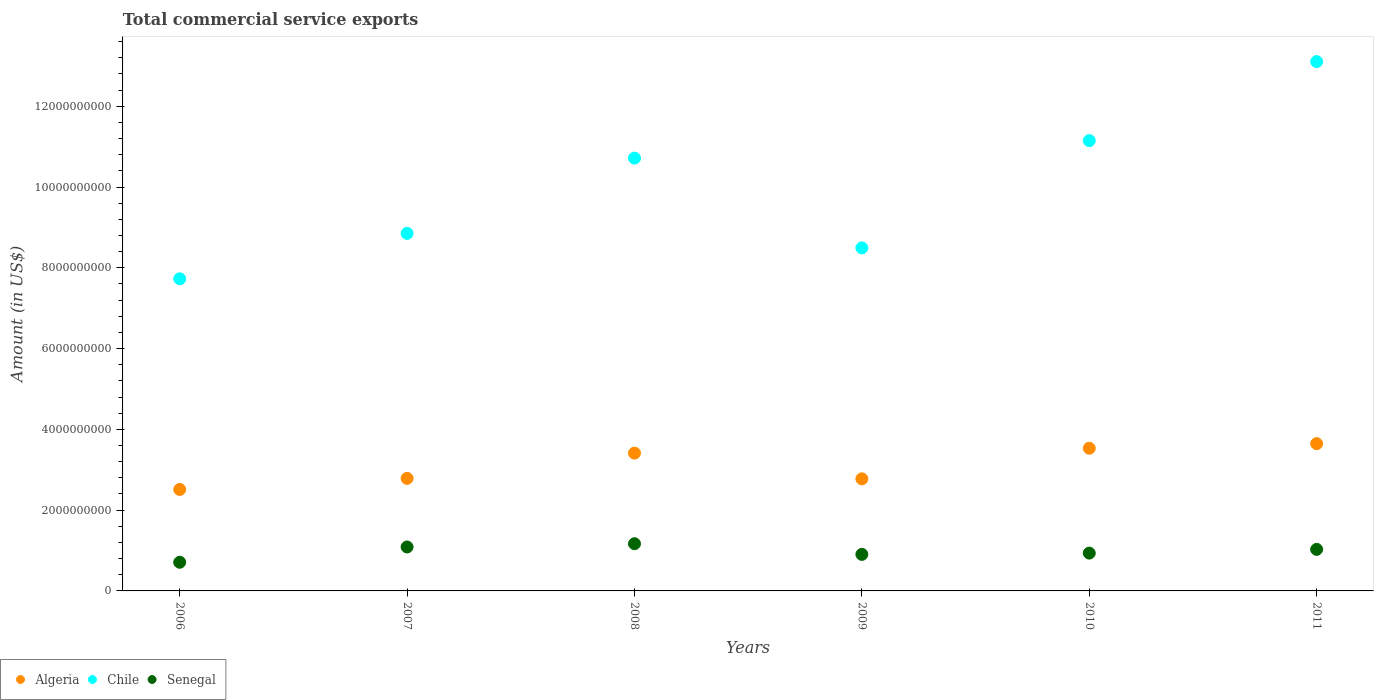How many different coloured dotlines are there?
Provide a short and direct response. 3. What is the total commercial service exports in Senegal in 2009?
Offer a terse response. 9.05e+08. Across all years, what is the maximum total commercial service exports in Algeria?
Your response must be concise. 3.65e+09. Across all years, what is the minimum total commercial service exports in Senegal?
Make the answer very short. 7.10e+08. In which year was the total commercial service exports in Algeria maximum?
Your answer should be compact. 2011. In which year was the total commercial service exports in Senegal minimum?
Your answer should be compact. 2006. What is the total total commercial service exports in Chile in the graph?
Ensure brevity in your answer.  6.00e+1. What is the difference between the total commercial service exports in Senegal in 2010 and that in 2011?
Make the answer very short. -9.23e+07. What is the difference between the total commercial service exports in Chile in 2006 and the total commercial service exports in Algeria in 2011?
Keep it short and to the point. 4.08e+09. What is the average total commercial service exports in Chile per year?
Make the answer very short. 1.00e+1. In the year 2006, what is the difference between the total commercial service exports in Algeria and total commercial service exports in Chile?
Ensure brevity in your answer.  -5.22e+09. In how many years, is the total commercial service exports in Chile greater than 9600000000 US$?
Ensure brevity in your answer.  3. What is the ratio of the total commercial service exports in Algeria in 2006 to that in 2007?
Provide a short and direct response. 0.9. What is the difference between the highest and the second highest total commercial service exports in Algeria?
Give a very brief answer. 1.14e+08. What is the difference between the highest and the lowest total commercial service exports in Chile?
Your answer should be very brief. 5.38e+09. In how many years, is the total commercial service exports in Senegal greater than the average total commercial service exports in Senegal taken over all years?
Make the answer very short. 3. Is the total commercial service exports in Senegal strictly greater than the total commercial service exports in Algeria over the years?
Provide a succinct answer. No. What is the difference between two consecutive major ticks on the Y-axis?
Keep it short and to the point. 2.00e+09. Are the values on the major ticks of Y-axis written in scientific E-notation?
Provide a succinct answer. No. Does the graph contain any zero values?
Ensure brevity in your answer.  No. Does the graph contain grids?
Offer a very short reply. No. Where does the legend appear in the graph?
Ensure brevity in your answer.  Bottom left. How many legend labels are there?
Give a very brief answer. 3. How are the legend labels stacked?
Provide a short and direct response. Horizontal. What is the title of the graph?
Make the answer very short. Total commercial service exports. Does "Korea (Democratic)" appear as one of the legend labels in the graph?
Keep it short and to the point. No. What is the label or title of the Y-axis?
Make the answer very short. Amount (in US$). What is the Amount (in US$) of Algeria in 2006?
Offer a terse response. 2.51e+09. What is the Amount (in US$) in Chile in 2006?
Offer a terse response. 7.73e+09. What is the Amount (in US$) of Senegal in 2006?
Give a very brief answer. 7.10e+08. What is the Amount (in US$) in Algeria in 2007?
Give a very brief answer. 2.79e+09. What is the Amount (in US$) of Chile in 2007?
Ensure brevity in your answer.  8.85e+09. What is the Amount (in US$) in Senegal in 2007?
Keep it short and to the point. 1.09e+09. What is the Amount (in US$) of Algeria in 2008?
Give a very brief answer. 3.41e+09. What is the Amount (in US$) of Chile in 2008?
Offer a terse response. 1.07e+1. What is the Amount (in US$) in Senegal in 2008?
Offer a terse response. 1.17e+09. What is the Amount (in US$) in Algeria in 2009?
Make the answer very short. 2.78e+09. What is the Amount (in US$) of Chile in 2009?
Ensure brevity in your answer.  8.49e+09. What is the Amount (in US$) in Senegal in 2009?
Provide a succinct answer. 9.05e+08. What is the Amount (in US$) in Algeria in 2010?
Ensure brevity in your answer.  3.53e+09. What is the Amount (in US$) of Chile in 2010?
Provide a succinct answer. 1.11e+1. What is the Amount (in US$) in Senegal in 2010?
Provide a succinct answer. 9.36e+08. What is the Amount (in US$) in Algeria in 2011?
Your answer should be compact. 3.65e+09. What is the Amount (in US$) in Chile in 2011?
Your response must be concise. 1.31e+1. What is the Amount (in US$) of Senegal in 2011?
Keep it short and to the point. 1.03e+09. Across all years, what is the maximum Amount (in US$) of Algeria?
Your answer should be very brief. 3.65e+09. Across all years, what is the maximum Amount (in US$) in Chile?
Give a very brief answer. 1.31e+1. Across all years, what is the maximum Amount (in US$) in Senegal?
Your response must be concise. 1.17e+09. Across all years, what is the minimum Amount (in US$) of Algeria?
Your answer should be very brief. 2.51e+09. Across all years, what is the minimum Amount (in US$) of Chile?
Provide a short and direct response. 7.73e+09. Across all years, what is the minimum Amount (in US$) in Senegal?
Keep it short and to the point. 7.10e+08. What is the total Amount (in US$) of Algeria in the graph?
Offer a terse response. 1.87e+1. What is the total Amount (in US$) of Chile in the graph?
Your response must be concise. 6.00e+1. What is the total Amount (in US$) in Senegal in the graph?
Offer a very short reply. 5.84e+09. What is the difference between the Amount (in US$) in Algeria in 2006 and that in 2007?
Offer a terse response. -2.75e+08. What is the difference between the Amount (in US$) of Chile in 2006 and that in 2007?
Your answer should be very brief. -1.12e+09. What is the difference between the Amount (in US$) of Senegal in 2006 and that in 2007?
Your answer should be very brief. -3.78e+08. What is the difference between the Amount (in US$) in Algeria in 2006 and that in 2008?
Ensure brevity in your answer.  -9.00e+08. What is the difference between the Amount (in US$) in Chile in 2006 and that in 2008?
Make the answer very short. -2.99e+09. What is the difference between the Amount (in US$) in Senegal in 2006 and that in 2008?
Your answer should be compact. -4.59e+08. What is the difference between the Amount (in US$) of Algeria in 2006 and that in 2009?
Your answer should be compact. -2.63e+08. What is the difference between the Amount (in US$) of Chile in 2006 and that in 2009?
Provide a short and direct response. -7.65e+08. What is the difference between the Amount (in US$) of Senegal in 2006 and that in 2009?
Offer a terse response. -1.95e+08. What is the difference between the Amount (in US$) in Algeria in 2006 and that in 2010?
Make the answer very short. -1.02e+09. What is the difference between the Amount (in US$) in Chile in 2006 and that in 2010?
Provide a short and direct response. -3.42e+09. What is the difference between the Amount (in US$) of Senegal in 2006 and that in 2010?
Keep it short and to the point. -2.27e+08. What is the difference between the Amount (in US$) in Algeria in 2006 and that in 2011?
Your answer should be very brief. -1.13e+09. What is the difference between the Amount (in US$) of Chile in 2006 and that in 2011?
Your answer should be very brief. -5.38e+09. What is the difference between the Amount (in US$) of Senegal in 2006 and that in 2011?
Your answer should be compact. -3.19e+08. What is the difference between the Amount (in US$) in Algeria in 2007 and that in 2008?
Provide a succinct answer. -6.26e+08. What is the difference between the Amount (in US$) of Chile in 2007 and that in 2008?
Offer a terse response. -1.86e+09. What is the difference between the Amount (in US$) in Senegal in 2007 and that in 2008?
Give a very brief answer. -8.07e+07. What is the difference between the Amount (in US$) of Algeria in 2007 and that in 2009?
Your answer should be very brief. 1.13e+07. What is the difference between the Amount (in US$) in Chile in 2007 and that in 2009?
Ensure brevity in your answer.  3.59e+08. What is the difference between the Amount (in US$) of Senegal in 2007 and that in 2009?
Ensure brevity in your answer.  1.83e+08. What is the difference between the Amount (in US$) of Algeria in 2007 and that in 2010?
Your answer should be compact. -7.46e+08. What is the difference between the Amount (in US$) of Chile in 2007 and that in 2010?
Provide a succinct answer. -2.30e+09. What is the difference between the Amount (in US$) in Senegal in 2007 and that in 2010?
Provide a succinct answer. 1.52e+08. What is the difference between the Amount (in US$) in Algeria in 2007 and that in 2011?
Your answer should be very brief. -8.60e+08. What is the difference between the Amount (in US$) of Chile in 2007 and that in 2011?
Keep it short and to the point. -4.25e+09. What is the difference between the Amount (in US$) in Senegal in 2007 and that in 2011?
Offer a terse response. 5.92e+07. What is the difference between the Amount (in US$) of Algeria in 2008 and that in 2009?
Your answer should be very brief. 6.37e+08. What is the difference between the Amount (in US$) in Chile in 2008 and that in 2009?
Your answer should be compact. 2.22e+09. What is the difference between the Amount (in US$) in Senegal in 2008 and that in 2009?
Ensure brevity in your answer.  2.64e+08. What is the difference between the Amount (in US$) of Algeria in 2008 and that in 2010?
Keep it short and to the point. -1.21e+08. What is the difference between the Amount (in US$) in Chile in 2008 and that in 2010?
Keep it short and to the point. -4.33e+08. What is the difference between the Amount (in US$) of Senegal in 2008 and that in 2010?
Make the answer very short. 2.32e+08. What is the difference between the Amount (in US$) of Algeria in 2008 and that in 2011?
Provide a succinct answer. -2.35e+08. What is the difference between the Amount (in US$) in Chile in 2008 and that in 2011?
Offer a very short reply. -2.39e+09. What is the difference between the Amount (in US$) in Senegal in 2008 and that in 2011?
Keep it short and to the point. 1.40e+08. What is the difference between the Amount (in US$) in Algeria in 2009 and that in 2010?
Offer a terse response. -7.57e+08. What is the difference between the Amount (in US$) of Chile in 2009 and that in 2010?
Offer a very short reply. -2.66e+09. What is the difference between the Amount (in US$) in Senegal in 2009 and that in 2010?
Offer a very short reply. -3.16e+07. What is the difference between the Amount (in US$) in Algeria in 2009 and that in 2011?
Your response must be concise. -8.71e+08. What is the difference between the Amount (in US$) of Chile in 2009 and that in 2011?
Ensure brevity in your answer.  -4.61e+09. What is the difference between the Amount (in US$) of Senegal in 2009 and that in 2011?
Your response must be concise. -1.24e+08. What is the difference between the Amount (in US$) of Algeria in 2010 and that in 2011?
Ensure brevity in your answer.  -1.14e+08. What is the difference between the Amount (in US$) of Chile in 2010 and that in 2011?
Your answer should be very brief. -1.96e+09. What is the difference between the Amount (in US$) of Senegal in 2010 and that in 2011?
Your answer should be very brief. -9.23e+07. What is the difference between the Amount (in US$) in Algeria in 2006 and the Amount (in US$) in Chile in 2007?
Offer a terse response. -6.34e+09. What is the difference between the Amount (in US$) in Algeria in 2006 and the Amount (in US$) in Senegal in 2007?
Your answer should be compact. 1.42e+09. What is the difference between the Amount (in US$) of Chile in 2006 and the Amount (in US$) of Senegal in 2007?
Ensure brevity in your answer.  6.64e+09. What is the difference between the Amount (in US$) of Algeria in 2006 and the Amount (in US$) of Chile in 2008?
Offer a very short reply. -8.20e+09. What is the difference between the Amount (in US$) in Algeria in 2006 and the Amount (in US$) in Senegal in 2008?
Provide a short and direct response. 1.34e+09. What is the difference between the Amount (in US$) of Chile in 2006 and the Amount (in US$) of Senegal in 2008?
Your answer should be very brief. 6.56e+09. What is the difference between the Amount (in US$) in Algeria in 2006 and the Amount (in US$) in Chile in 2009?
Ensure brevity in your answer.  -5.98e+09. What is the difference between the Amount (in US$) in Algeria in 2006 and the Amount (in US$) in Senegal in 2009?
Offer a very short reply. 1.61e+09. What is the difference between the Amount (in US$) of Chile in 2006 and the Amount (in US$) of Senegal in 2009?
Offer a very short reply. 6.82e+09. What is the difference between the Amount (in US$) of Algeria in 2006 and the Amount (in US$) of Chile in 2010?
Offer a very short reply. -8.64e+09. What is the difference between the Amount (in US$) in Algeria in 2006 and the Amount (in US$) in Senegal in 2010?
Ensure brevity in your answer.  1.58e+09. What is the difference between the Amount (in US$) of Chile in 2006 and the Amount (in US$) of Senegal in 2010?
Your answer should be compact. 6.79e+09. What is the difference between the Amount (in US$) in Algeria in 2006 and the Amount (in US$) in Chile in 2011?
Give a very brief answer. -1.06e+1. What is the difference between the Amount (in US$) in Algeria in 2006 and the Amount (in US$) in Senegal in 2011?
Give a very brief answer. 1.48e+09. What is the difference between the Amount (in US$) of Chile in 2006 and the Amount (in US$) of Senegal in 2011?
Provide a succinct answer. 6.70e+09. What is the difference between the Amount (in US$) of Algeria in 2007 and the Amount (in US$) of Chile in 2008?
Your answer should be compact. -7.93e+09. What is the difference between the Amount (in US$) in Algeria in 2007 and the Amount (in US$) in Senegal in 2008?
Keep it short and to the point. 1.62e+09. What is the difference between the Amount (in US$) in Chile in 2007 and the Amount (in US$) in Senegal in 2008?
Offer a terse response. 7.68e+09. What is the difference between the Amount (in US$) in Algeria in 2007 and the Amount (in US$) in Chile in 2009?
Provide a succinct answer. -5.71e+09. What is the difference between the Amount (in US$) of Algeria in 2007 and the Amount (in US$) of Senegal in 2009?
Provide a short and direct response. 1.88e+09. What is the difference between the Amount (in US$) in Chile in 2007 and the Amount (in US$) in Senegal in 2009?
Offer a very short reply. 7.95e+09. What is the difference between the Amount (in US$) in Algeria in 2007 and the Amount (in US$) in Chile in 2010?
Offer a terse response. -8.36e+09. What is the difference between the Amount (in US$) in Algeria in 2007 and the Amount (in US$) in Senegal in 2010?
Keep it short and to the point. 1.85e+09. What is the difference between the Amount (in US$) in Chile in 2007 and the Amount (in US$) in Senegal in 2010?
Make the answer very short. 7.92e+09. What is the difference between the Amount (in US$) in Algeria in 2007 and the Amount (in US$) in Chile in 2011?
Offer a very short reply. -1.03e+1. What is the difference between the Amount (in US$) in Algeria in 2007 and the Amount (in US$) in Senegal in 2011?
Provide a short and direct response. 1.76e+09. What is the difference between the Amount (in US$) of Chile in 2007 and the Amount (in US$) of Senegal in 2011?
Keep it short and to the point. 7.82e+09. What is the difference between the Amount (in US$) in Algeria in 2008 and the Amount (in US$) in Chile in 2009?
Ensure brevity in your answer.  -5.08e+09. What is the difference between the Amount (in US$) in Algeria in 2008 and the Amount (in US$) in Senegal in 2009?
Make the answer very short. 2.51e+09. What is the difference between the Amount (in US$) in Chile in 2008 and the Amount (in US$) in Senegal in 2009?
Provide a short and direct response. 9.81e+09. What is the difference between the Amount (in US$) of Algeria in 2008 and the Amount (in US$) of Chile in 2010?
Offer a very short reply. -7.74e+09. What is the difference between the Amount (in US$) in Algeria in 2008 and the Amount (in US$) in Senegal in 2010?
Keep it short and to the point. 2.48e+09. What is the difference between the Amount (in US$) of Chile in 2008 and the Amount (in US$) of Senegal in 2010?
Provide a short and direct response. 9.78e+09. What is the difference between the Amount (in US$) of Algeria in 2008 and the Amount (in US$) of Chile in 2011?
Your response must be concise. -9.69e+09. What is the difference between the Amount (in US$) of Algeria in 2008 and the Amount (in US$) of Senegal in 2011?
Give a very brief answer. 2.38e+09. What is the difference between the Amount (in US$) in Chile in 2008 and the Amount (in US$) in Senegal in 2011?
Give a very brief answer. 9.69e+09. What is the difference between the Amount (in US$) of Algeria in 2009 and the Amount (in US$) of Chile in 2010?
Make the answer very short. -8.37e+09. What is the difference between the Amount (in US$) in Algeria in 2009 and the Amount (in US$) in Senegal in 2010?
Offer a very short reply. 1.84e+09. What is the difference between the Amount (in US$) in Chile in 2009 and the Amount (in US$) in Senegal in 2010?
Provide a succinct answer. 7.56e+09. What is the difference between the Amount (in US$) of Algeria in 2009 and the Amount (in US$) of Chile in 2011?
Your answer should be compact. -1.03e+1. What is the difference between the Amount (in US$) in Algeria in 2009 and the Amount (in US$) in Senegal in 2011?
Keep it short and to the point. 1.75e+09. What is the difference between the Amount (in US$) in Chile in 2009 and the Amount (in US$) in Senegal in 2011?
Provide a succinct answer. 7.46e+09. What is the difference between the Amount (in US$) of Algeria in 2010 and the Amount (in US$) of Chile in 2011?
Your answer should be very brief. -9.57e+09. What is the difference between the Amount (in US$) of Algeria in 2010 and the Amount (in US$) of Senegal in 2011?
Keep it short and to the point. 2.50e+09. What is the difference between the Amount (in US$) of Chile in 2010 and the Amount (in US$) of Senegal in 2011?
Your response must be concise. 1.01e+1. What is the average Amount (in US$) of Algeria per year?
Keep it short and to the point. 3.11e+09. What is the average Amount (in US$) in Chile per year?
Your response must be concise. 1.00e+1. What is the average Amount (in US$) of Senegal per year?
Offer a very short reply. 9.73e+08. In the year 2006, what is the difference between the Amount (in US$) of Algeria and Amount (in US$) of Chile?
Your response must be concise. -5.22e+09. In the year 2006, what is the difference between the Amount (in US$) of Algeria and Amount (in US$) of Senegal?
Give a very brief answer. 1.80e+09. In the year 2006, what is the difference between the Amount (in US$) of Chile and Amount (in US$) of Senegal?
Provide a succinct answer. 7.02e+09. In the year 2007, what is the difference between the Amount (in US$) of Algeria and Amount (in US$) of Chile?
Keep it short and to the point. -6.07e+09. In the year 2007, what is the difference between the Amount (in US$) of Algeria and Amount (in US$) of Senegal?
Your response must be concise. 1.70e+09. In the year 2007, what is the difference between the Amount (in US$) of Chile and Amount (in US$) of Senegal?
Offer a terse response. 7.76e+09. In the year 2008, what is the difference between the Amount (in US$) in Algeria and Amount (in US$) in Chile?
Ensure brevity in your answer.  -7.30e+09. In the year 2008, what is the difference between the Amount (in US$) of Algeria and Amount (in US$) of Senegal?
Your answer should be very brief. 2.24e+09. In the year 2008, what is the difference between the Amount (in US$) in Chile and Amount (in US$) in Senegal?
Offer a very short reply. 9.55e+09. In the year 2009, what is the difference between the Amount (in US$) in Algeria and Amount (in US$) in Chile?
Ensure brevity in your answer.  -5.72e+09. In the year 2009, what is the difference between the Amount (in US$) in Algeria and Amount (in US$) in Senegal?
Provide a short and direct response. 1.87e+09. In the year 2009, what is the difference between the Amount (in US$) of Chile and Amount (in US$) of Senegal?
Give a very brief answer. 7.59e+09. In the year 2010, what is the difference between the Amount (in US$) of Algeria and Amount (in US$) of Chile?
Your response must be concise. -7.62e+09. In the year 2010, what is the difference between the Amount (in US$) in Algeria and Amount (in US$) in Senegal?
Keep it short and to the point. 2.60e+09. In the year 2010, what is the difference between the Amount (in US$) of Chile and Amount (in US$) of Senegal?
Make the answer very short. 1.02e+1. In the year 2011, what is the difference between the Amount (in US$) in Algeria and Amount (in US$) in Chile?
Your answer should be very brief. -9.46e+09. In the year 2011, what is the difference between the Amount (in US$) of Algeria and Amount (in US$) of Senegal?
Your response must be concise. 2.62e+09. In the year 2011, what is the difference between the Amount (in US$) in Chile and Amount (in US$) in Senegal?
Offer a terse response. 1.21e+1. What is the ratio of the Amount (in US$) in Algeria in 2006 to that in 2007?
Make the answer very short. 0.9. What is the ratio of the Amount (in US$) of Chile in 2006 to that in 2007?
Offer a terse response. 0.87. What is the ratio of the Amount (in US$) of Senegal in 2006 to that in 2007?
Provide a succinct answer. 0.65. What is the ratio of the Amount (in US$) in Algeria in 2006 to that in 2008?
Your answer should be very brief. 0.74. What is the ratio of the Amount (in US$) in Chile in 2006 to that in 2008?
Offer a very short reply. 0.72. What is the ratio of the Amount (in US$) in Senegal in 2006 to that in 2008?
Your answer should be very brief. 0.61. What is the ratio of the Amount (in US$) of Algeria in 2006 to that in 2009?
Make the answer very short. 0.91. What is the ratio of the Amount (in US$) of Chile in 2006 to that in 2009?
Offer a very short reply. 0.91. What is the ratio of the Amount (in US$) in Senegal in 2006 to that in 2009?
Provide a succinct answer. 0.78. What is the ratio of the Amount (in US$) in Algeria in 2006 to that in 2010?
Provide a short and direct response. 0.71. What is the ratio of the Amount (in US$) of Chile in 2006 to that in 2010?
Ensure brevity in your answer.  0.69. What is the ratio of the Amount (in US$) in Senegal in 2006 to that in 2010?
Provide a short and direct response. 0.76. What is the ratio of the Amount (in US$) in Algeria in 2006 to that in 2011?
Your answer should be compact. 0.69. What is the ratio of the Amount (in US$) in Chile in 2006 to that in 2011?
Offer a very short reply. 0.59. What is the ratio of the Amount (in US$) in Senegal in 2006 to that in 2011?
Make the answer very short. 0.69. What is the ratio of the Amount (in US$) of Algeria in 2007 to that in 2008?
Offer a very short reply. 0.82. What is the ratio of the Amount (in US$) in Chile in 2007 to that in 2008?
Offer a terse response. 0.83. What is the ratio of the Amount (in US$) of Senegal in 2007 to that in 2008?
Keep it short and to the point. 0.93. What is the ratio of the Amount (in US$) in Algeria in 2007 to that in 2009?
Your response must be concise. 1. What is the ratio of the Amount (in US$) of Chile in 2007 to that in 2009?
Offer a very short reply. 1.04. What is the ratio of the Amount (in US$) of Senegal in 2007 to that in 2009?
Your response must be concise. 1.2. What is the ratio of the Amount (in US$) in Algeria in 2007 to that in 2010?
Provide a short and direct response. 0.79. What is the ratio of the Amount (in US$) of Chile in 2007 to that in 2010?
Give a very brief answer. 0.79. What is the ratio of the Amount (in US$) in Senegal in 2007 to that in 2010?
Make the answer very short. 1.16. What is the ratio of the Amount (in US$) in Algeria in 2007 to that in 2011?
Ensure brevity in your answer.  0.76. What is the ratio of the Amount (in US$) in Chile in 2007 to that in 2011?
Provide a succinct answer. 0.68. What is the ratio of the Amount (in US$) of Senegal in 2007 to that in 2011?
Give a very brief answer. 1.06. What is the ratio of the Amount (in US$) of Algeria in 2008 to that in 2009?
Keep it short and to the point. 1.23. What is the ratio of the Amount (in US$) of Chile in 2008 to that in 2009?
Provide a succinct answer. 1.26. What is the ratio of the Amount (in US$) in Senegal in 2008 to that in 2009?
Offer a very short reply. 1.29. What is the ratio of the Amount (in US$) in Algeria in 2008 to that in 2010?
Make the answer very short. 0.97. What is the ratio of the Amount (in US$) of Chile in 2008 to that in 2010?
Your response must be concise. 0.96. What is the ratio of the Amount (in US$) in Senegal in 2008 to that in 2010?
Your answer should be very brief. 1.25. What is the ratio of the Amount (in US$) of Algeria in 2008 to that in 2011?
Your response must be concise. 0.94. What is the ratio of the Amount (in US$) in Chile in 2008 to that in 2011?
Make the answer very short. 0.82. What is the ratio of the Amount (in US$) in Senegal in 2008 to that in 2011?
Your answer should be very brief. 1.14. What is the ratio of the Amount (in US$) of Algeria in 2009 to that in 2010?
Your answer should be compact. 0.79. What is the ratio of the Amount (in US$) in Chile in 2009 to that in 2010?
Offer a terse response. 0.76. What is the ratio of the Amount (in US$) in Senegal in 2009 to that in 2010?
Your answer should be very brief. 0.97. What is the ratio of the Amount (in US$) in Algeria in 2009 to that in 2011?
Offer a terse response. 0.76. What is the ratio of the Amount (in US$) of Chile in 2009 to that in 2011?
Give a very brief answer. 0.65. What is the ratio of the Amount (in US$) in Senegal in 2009 to that in 2011?
Provide a short and direct response. 0.88. What is the ratio of the Amount (in US$) in Algeria in 2010 to that in 2011?
Make the answer very short. 0.97. What is the ratio of the Amount (in US$) of Chile in 2010 to that in 2011?
Offer a terse response. 0.85. What is the ratio of the Amount (in US$) of Senegal in 2010 to that in 2011?
Offer a very short reply. 0.91. What is the difference between the highest and the second highest Amount (in US$) of Algeria?
Provide a succinct answer. 1.14e+08. What is the difference between the highest and the second highest Amount (in US$) of Chile?
Offer a terse response. 1.96e+09. What is the difference between the highest and the second highest Amount (in US$) in Senegal?
Offer a very short reply. 8.07e+07. What is the difference between the highest and the lowest Amount (in US$) of Algeria?
Your answer should be very brief. 1.13e+09. What is the difference between the highest and the lowest Amount (in US$) of Chile?
Ensure brevity in your answer.  5.38e+09. What is the difference between the highest and the lowest Amount (in US$) of Senegal?
Make the answer very short. 4.59e+08. 